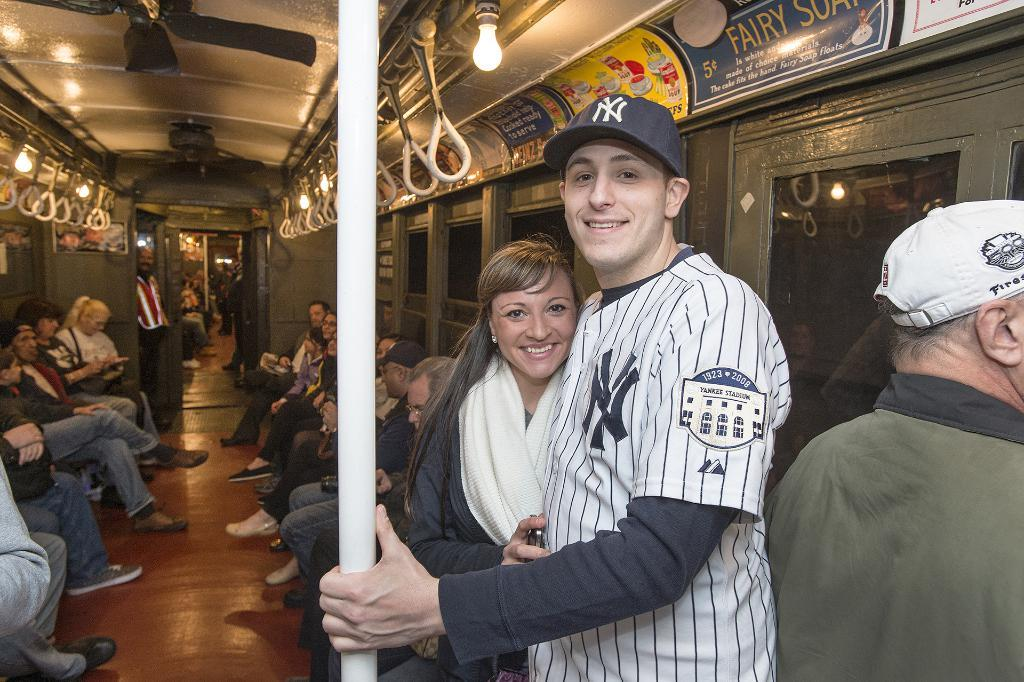<image>
Summarize the visual content of the image. Person standing on a train wearing a jersey that says NY on it. 